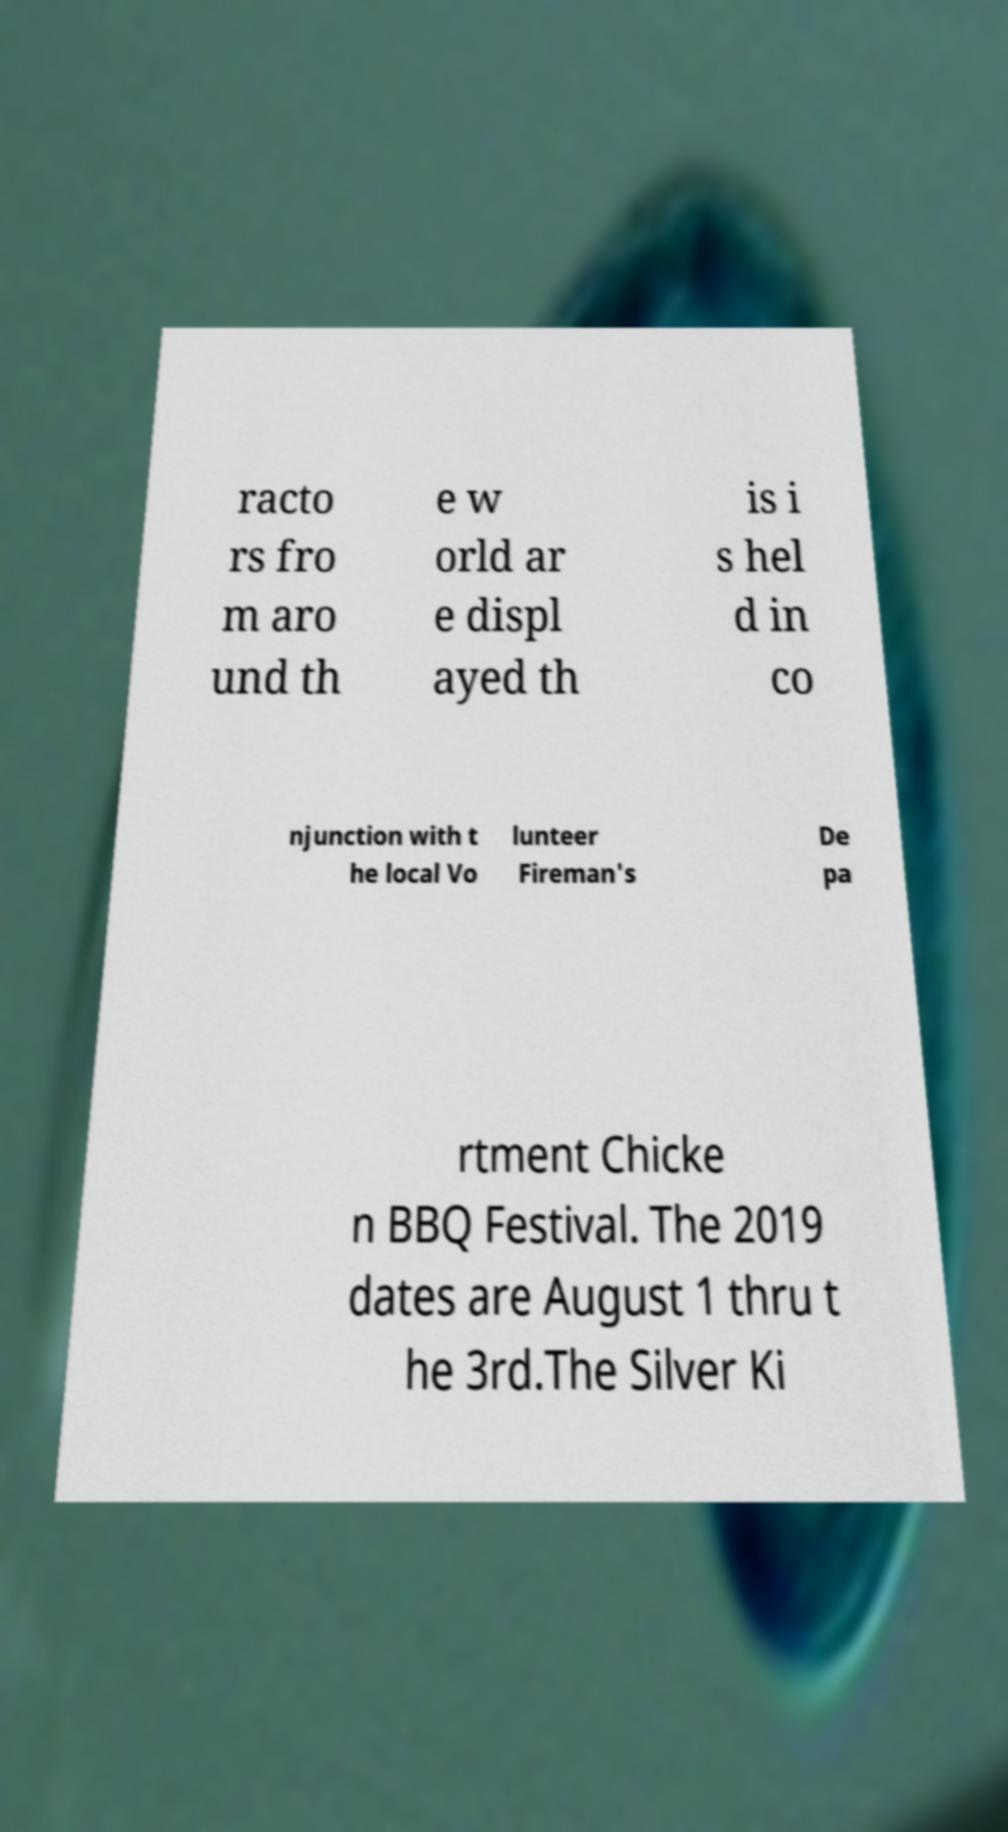Please read and relay the text visible in this image. What does it say? racto rs fro m aro und th e w orld ar e displ ayed th is i s hel d in co njunction with t he local Vo lunteer Fireman's De pa rtment Chicke n BBQ Festival. The 2019 dates are August 1 thru t he 3rd.The Silver Ki 